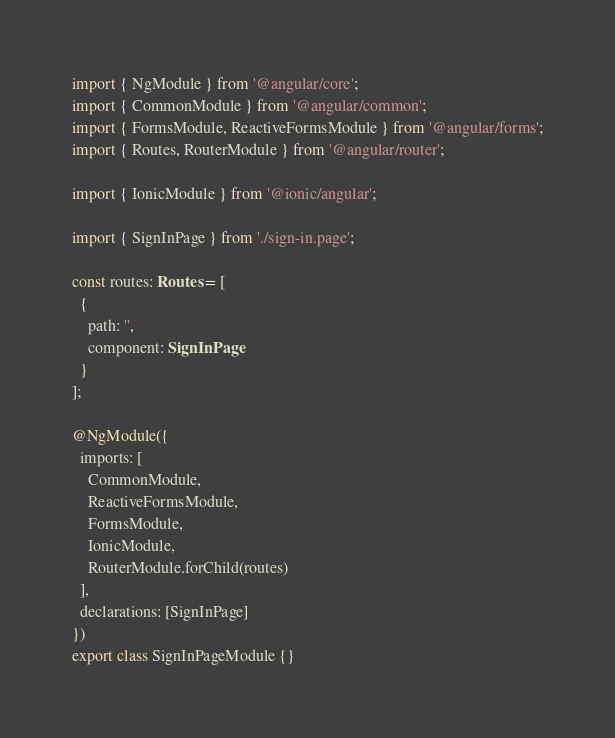<code> <loc_0><loc_0><loc_500><loc_500><_TypeScript_>import { NgModule } from '@angular/core';
import { CommonModule } from '@angular/common';
import { FormsModule, ReactiveFormsModule } from '@angular/forms';
import { Routes, RouterModule } from '@angular/router';

import { IonicModule } from '@ionic/angular';

import { SignInPage } from './sign-in.page';

const routes: Routes = [
  {
    path: '',
    component: SignInPage
  }
];

@NgModule({
  imports: [
    CommonModule,
    ReactiveFormsModule,
    FormsModule,
    IonicModule,
    RouterModule.forChild(routes)
  ],
  declarations: [SignInPage]
})
export class SignInPageModule {}
</code> 